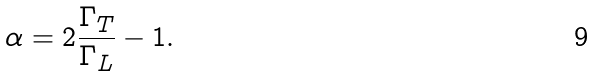Convert formula to latex. <formula><loc_0><loc_0><loc_500><loc_500>\alpha = 2 \frac { \Gamma _ { T } } { \Gamma _ { L } } - 1 .</formula> 